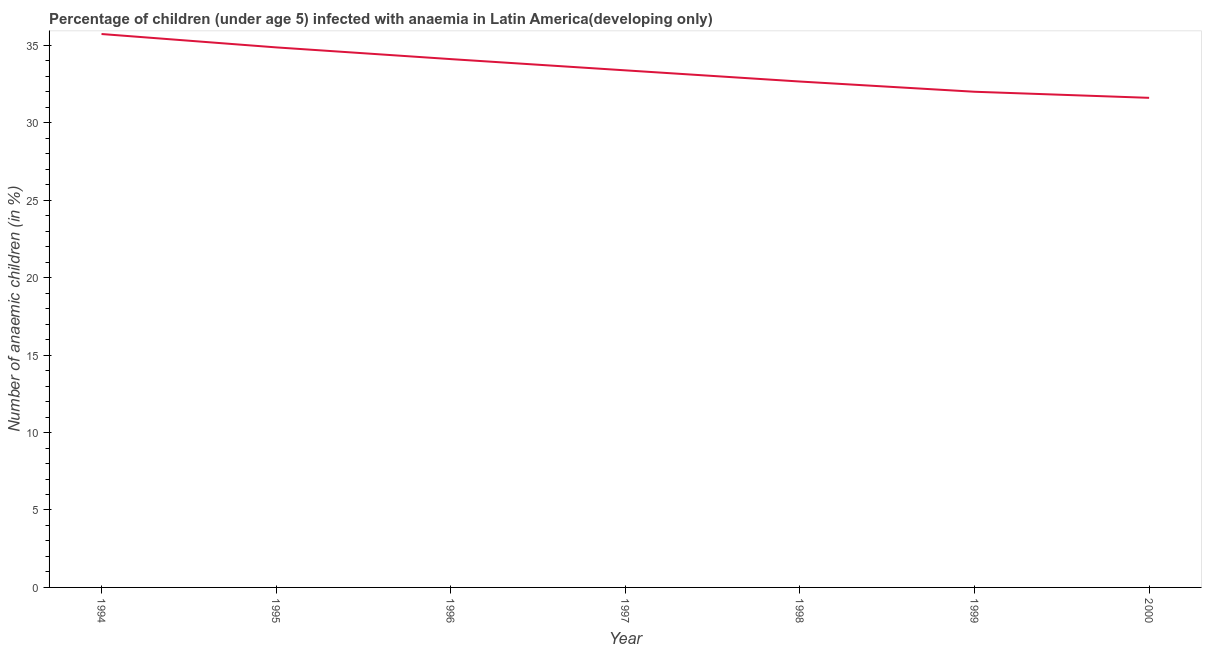What is the number of anaemic children in 1998?
Provide a short and direct response. 32.66. Across all years, what is the maximum number of anaemic children?
Provide a succinct answer. 35.73. Across all years, what is the minimum number of anaemic children?
Your answer should be compact. 31.61. In which year was the number of anaemic children maximum?
Your response must be concise. 1994. What is the sum of the number of anaemic children?
Keep it short and to the point. 234.36. What is the difference between the number of anaemic children in 1997 and 2000?
Your response must be concise. 1.78. What is the average number of anaemic children per year?
Offer a terse response. 33.48. What is the median number of anaemic children?
Offer a very short reply. 33.38. Do a majority of the years between 1995 and 1999 (inclusive) have number of anaemic children greater than 21 %?
Your answer should be very brief. Yes. What is the ratio of the number of anaemic children in 1998 to that in 1999?
Provide a succinct answer. 1.02. Is the number of anaemic children in 1994 less than that in 1999?
Offer a terse response. No. What is the difference between the highest and the second highest number of anaemic children?
Make the answer very short. 0.86. What is the difference between the highest and the lowest number of anaemic children?
Keep it short and to the point. 4.12. Does the number of anaemic children monotonically increase over the years?
Make the answer very short. No. Are the values on the major ticks of Y-axis written in scientific E-notation?
Your answer should be compact. No. Does the graph contain grids?
Make the answer very short. No. What is the title of the graph?
Offer a very short reply. Percentage of children (under age 5) infected with anaemia in Latin America(developing only). What is the label or title of the Y-axis?
Your answer should be very brief. Number of anaemic children (in %). What is the Number of anaemic children (in %) of 1994?
Ensure brevity in your answer.  35.73. What is the Number of anaemic children (in %) in 1995?
Make the answer very short. 34.87. What is the Number of anaemic children (in %) of 1996?
Give a very brief answer. 34.11. What is the Number of anaemic children (in %) in 1997?
Your response must be concise. 33.38. What is the Number of anaemic children (in %) of 1998?
Give a very brief answer. 32.66. What is the Number of anaemic children (in %) of 1999?
Ensure brevity in your answer.  32. What is the Number of anaemic children (in %) in 2000?
Ensure brevity in your answer.  31.61. What is the difference between the Number of anaemic children (in %) in 1994 and 1995?
Ensure brevity in your answer.  0.86. What is the difference between the Number of anaemic children (in %) in 1994 and 1996?
Give a very brief answer. 1.62. What is the difference between the Number of anaemic children (in %) in 1994 and 1997?
Make the answer very short. 2.35. What is the difference between the Number of anaemic children (in %) in 1994 and 1998?
Provide a short and direct response. 3.07. What is the difference between the Number of anaemic children (in %) in 1994 and 1999?
Your response must be concise. 3.73. What is the difference between the Number of anaemic children (in %) in 1994 and 2000?
Offer a very short reply. 4.12. What is the difference between the Number of anaemic children (in %) in 1995 and 1996?
Provide a short and direct response. 0.76. What is the difference between the Number of anaemic children (in %) in 1995 and 1997?
Ensure brevity in your answer.  1.48. What is the difference between the Number of anaemic children (in %) in 1995 and 1998?
Offer a very short reply. 2.21. What is the difference between the Number of anaemic children (in %) in 1995 and 1999?
Make the answer very short. 2.86. What is the difference between the Number of anaemic children (in %) in 1995 and 2000?
Offer a very short reply. 3.26. What is the difference between the Number of anaemic children (in %) in 1996 and 1997?
Your answer should be very brief. 0.73. What is the difference between the Number of anaemic children (in %) in 1996 and 1998?
Your response must be concise. 1.45. What is the difference between the Number of anaemic children (in %) in 1996 and 1999?
Offer a very short reply. 2.11. What is the difference between the Number of anaemic children (in %) in 1996 and 2000?
Your answer should be compact. 2.5. What is the difference between the Number of anaemic children (in %) in 1997 and 1998?
Your answer should be compact. 0.72. What is the difference between the Number of anaemic children (in %) in 1997 and 1999?
Your answer should be compact. 1.38. What is the difference between the Number of anaemic children (in %) in 1997 and 2000?
Your answer should be compact. 1.78. What is the difference between the Number of anaemic children (in %) in 1998 and 1999?
Keep it short and to the point. 0.66. What is the difference between the Number of anaemic children (in %) in 1998 and 2000?
Make the answer very short. 1.05. What is the difference between the Number of anaemic children (in %) in 1999 and 2000?
Provide a short and direct response. 0.39. What is the ratio of the Number of anaemic children (in %) in 1994 to that in 1996?
Offer a very short reply. 1.05. What is the ratio of the Number of anaemic children (in %) in 1994 to that in 1997?
Your answer should be very brief. 1.07. What is the ratio of the Number of anaemic children (in %) in 1994 to that in 1998?
Ensure brevity in your answer.  1.09. What is the ratio of the Number of anaemic children (in %) in 1994 to that in 1999?
Keep it short and to the point. 1.12. What is the ratio of the Number of anaemic children (in %) in 1994 to that in 2000?
Ensure brevity in your answer.  1.13. What is the ratio of the Number of anaemic children (in %) in 1995 to that in 1997?
Offer a terse response. 1.04. What is the ratio of the Number of anaemic children (in %) in 1995 to that in 1998?
Offer a terse response. 1.07. What is the ratio of the Number of anaemic children (in %) in 1995 to that in 1999?
Give a very brief answer. 1.09. What is the ratio of the Number of anaemic children (in %) in 1995 to that in 2000?
Offer a very short reply. 1.1. What is the ratio of the Number of anaemic children (in %) in 1996 to that in 1998?
Offer a terse response. 1.04. What is the ratio of the Number of anaemic children (in %) in 1996 to that in 1999?
Provide a succinct answer. 1.07. What is the ratio of the Number of anaemic children (in %) in 1996 to that in 2000?
Provide a short and direct response. 1.08. What is the ratio of the Number of anaemic children (in %) in 1997 to that in 1999?
Provide a short and direct response. 1.04. What is the ratio of the Number of anaemic children (in %) in 1997 to that in 2000?
Provide a succinct answer. 1.06. What is the ratio of the Number of anaemic children (in %) in 1998 to that in 2000?
Provide a succinct answer. 1.03. What is the ratio of the Number of anaemic children (in %) in 1999 to that in 2000?
Provide a succinct answer. 1.01. 